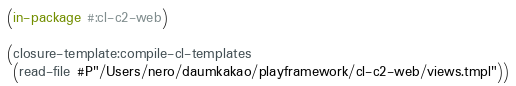<code> <loc_0><loc_0><loc_500><loc_500><_Lisp_>(in-package #:cl-c2-web)

(closure-template:compile-cl-templates
 (read-file #P"/Users/nero/daumkakao/playframework/cl-c2-web/views.tmpl"))
</code> 